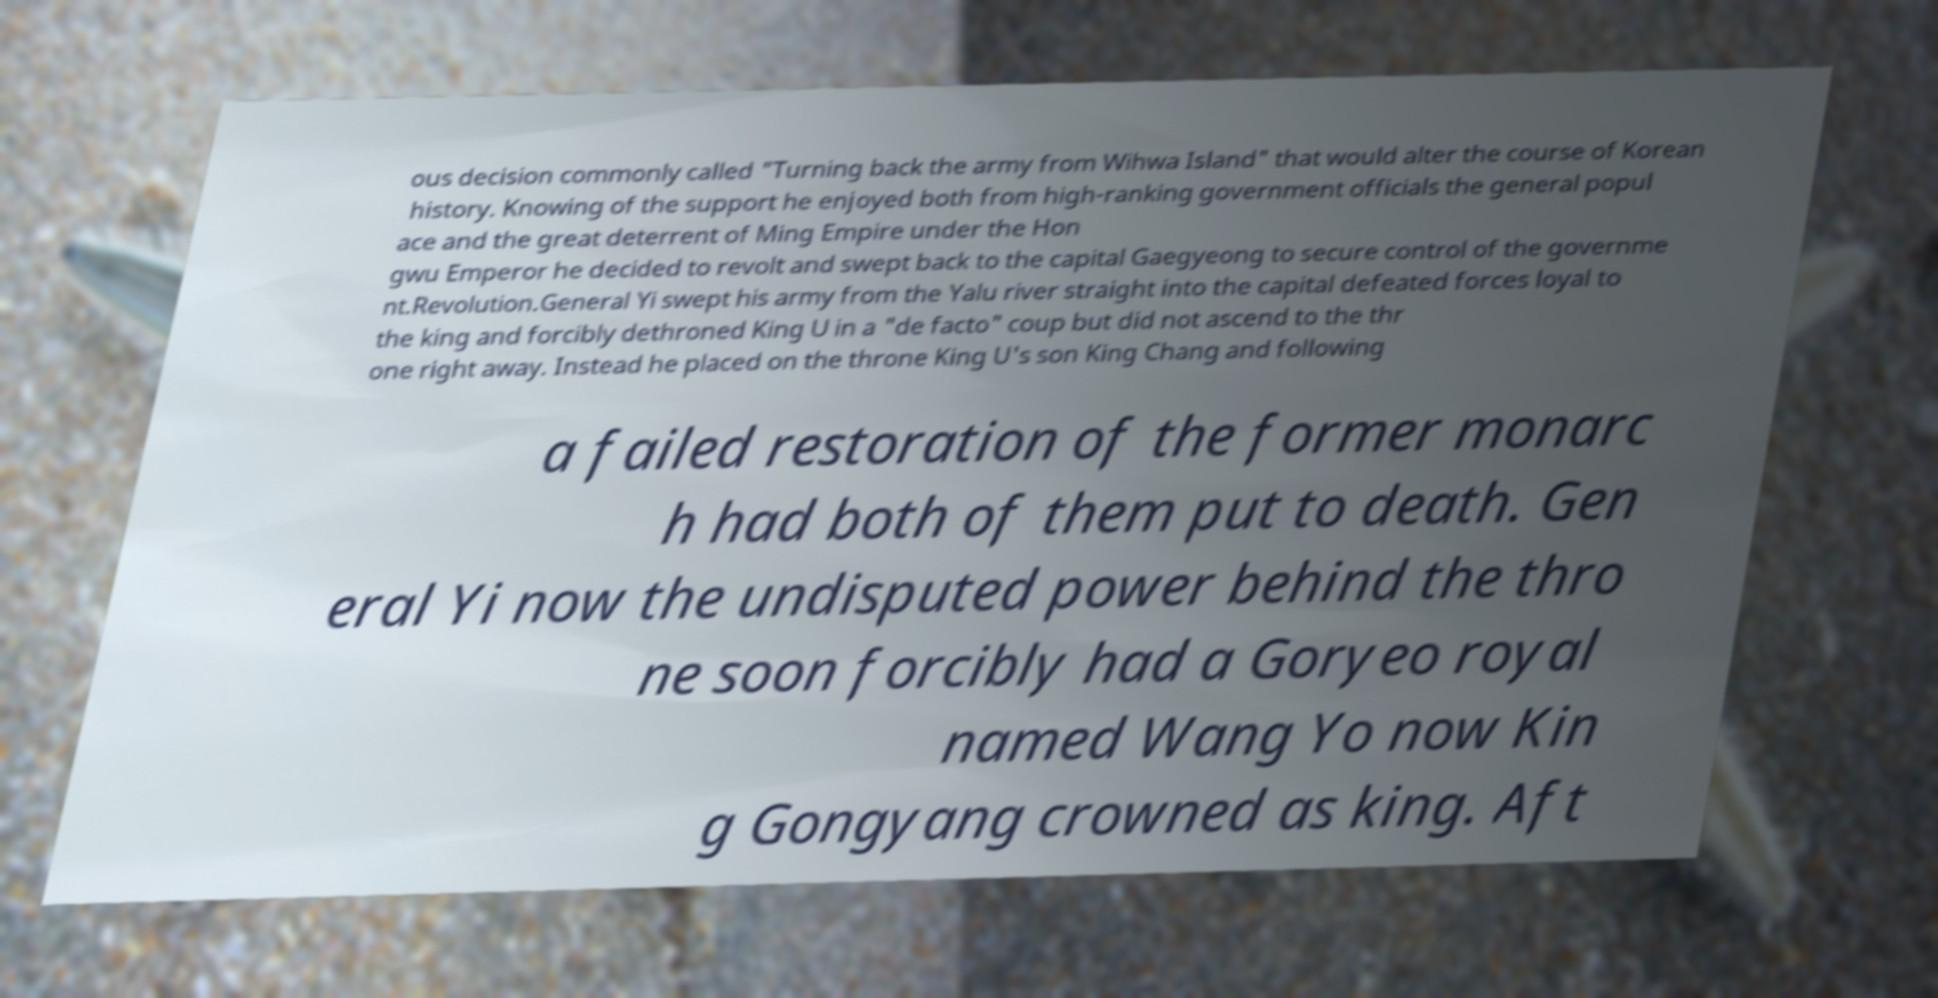Please identify and transcribe the text found in this image. ous decision commonly called "Turning back the army from Wihwa Island" that would alter the course of Korean history. Knowing of the support he enjoyed both from high-ranking government officials the general popul ace and the great deterrent of Ming Empire under the Hon gwu Emperor he decided to revolt and swept back to the capital Gaegyeong to secure control of the governme nt.Revolution.General Yi swept his army from the Yalu river straight into the capital defeated forces loyal to the king and forcibly dethroned King U in a "de facto" coup but did not ascend to the thr one right away. Instead he placed on the throne King U's son King Chang and following a failed restoration of the former monarc h had both of them put to death. Gen eral Yi now the undisputed power behind the thro ne soon forcibly had a Goryeo royal named Wang Yo now Kin g Gongyang crowned as king. Aft 